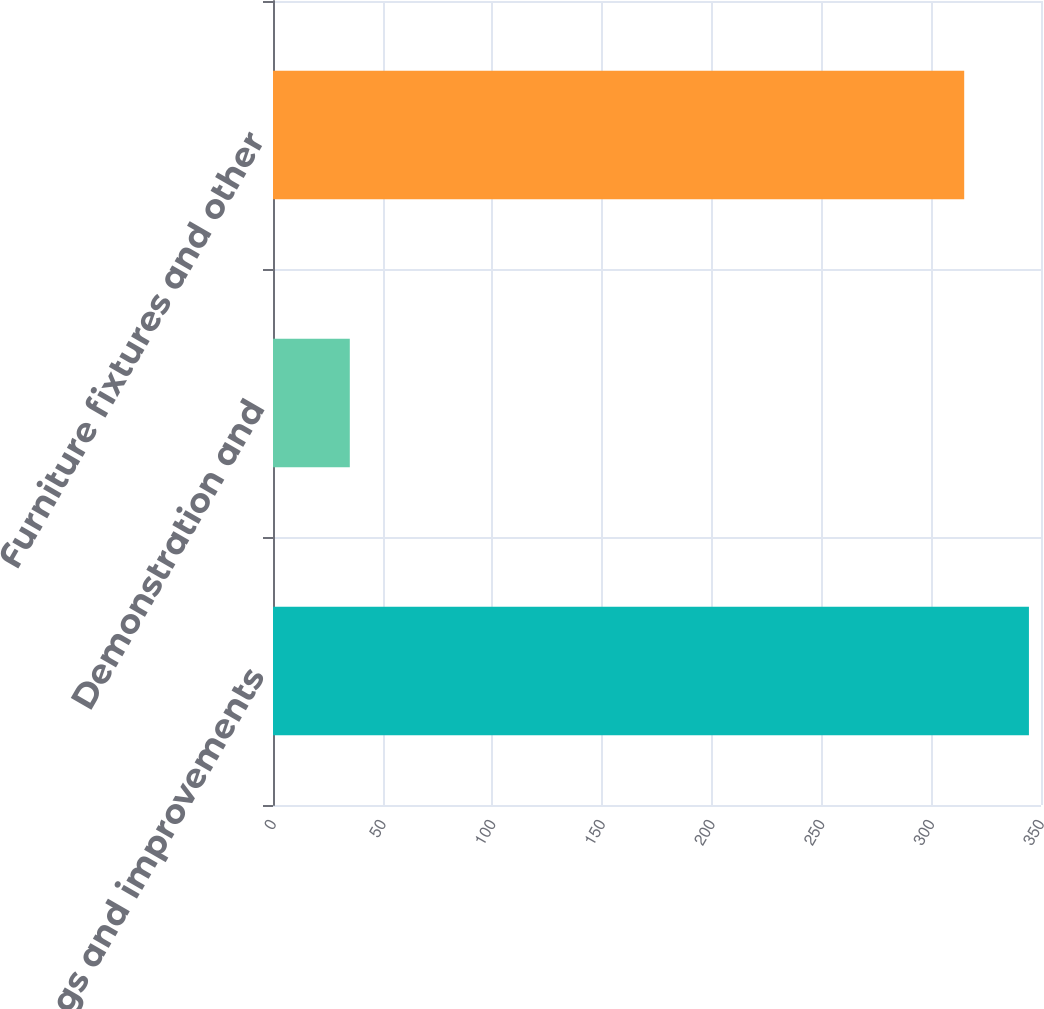Convert chart to OTSL. <chart><loc_0><loc_0><loc_500><loc_500><bar_chart><fcel>Buildings and improvements<fcel>Demonstration and<fcel>Furniture fixtures and other<nl><fcel>344.5<fcel>35<fcel>315<nl></chart> 